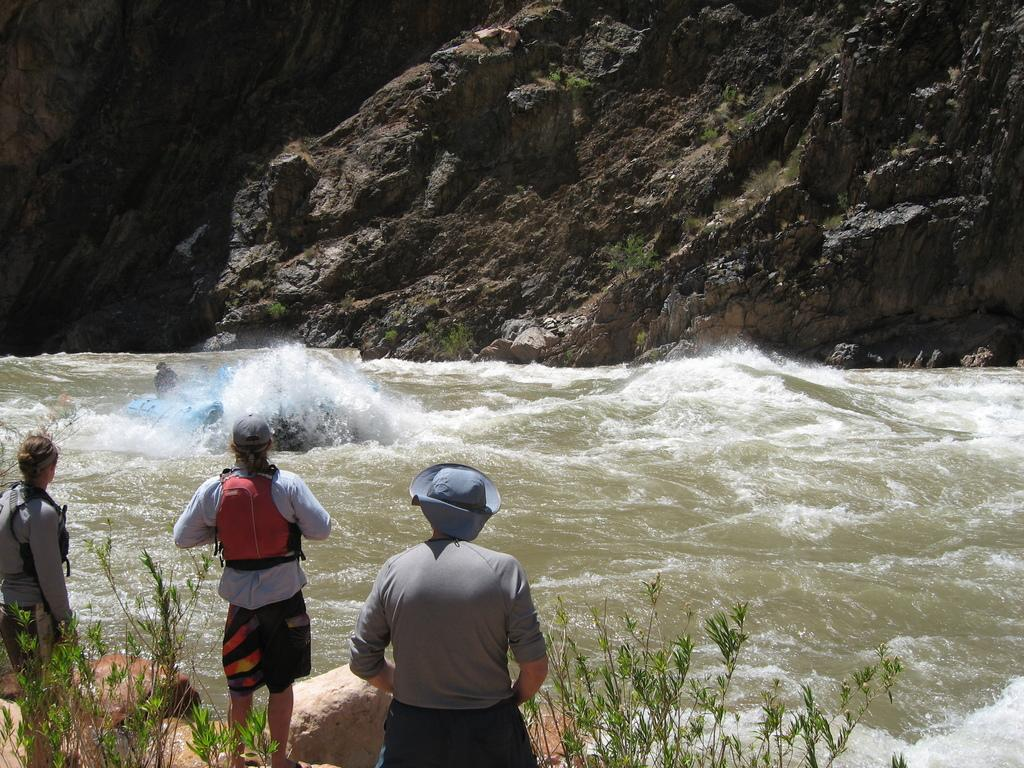What is the main setting of the image? The main setting of the image is near a lake. What are the people near the lake doing? There are people standing near the lake, and one person is sailing in the water. What type of vegetation can be seen in the image? Plants are visible in the image. What geographical feature can be seen in the background of the image? There is a mountain visible in the image. What type of surface can be seen near the lake? Stones are present in the image. What book is the person sailing reading in the image? There is no book visible in the image, as the person sailing is focused on navigating the water. What type of poison is present in the image? There is no poison present in the image; it features a peaceful scene near a lake with people and a sailboat. 